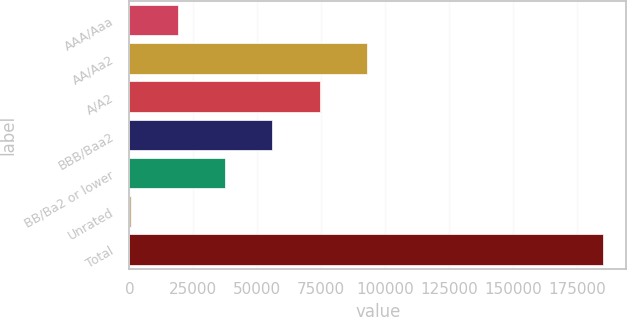<chart> <loc_0><loc_0><loc_500><loc_500><bar_chart><fcel>AAA/Aaa<fcel>AA/Aa2<fcel>A/A2<fcel>BBB/Baa2<fcel>BB/Ba2 or lower<fcel>Unrated<fcel>Total<nl><fcel>19047.8<fcel>92831<fcel>74385.2<fcel>55939.4<fcel>37493.6<fcel>602<fcel>185060<nl></chart> 